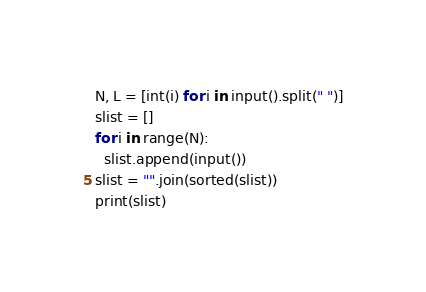Convert code to text. <code><loc_0><loc_0><loc_500><loc_500><_Python_>N, L = [int(i) for i in input().split(" ")]
slist = []
for i in range(N):
  slist.append(input())
slist = "".join(sorted(slist))
print(slist)</code> 